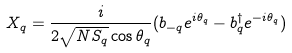Convert formula to latex. <formula><loc_0><loc_0><loc_500><loc_500>X _ { q } = \frac { i } { 2 \sqrt { N S _ { q } } \cos \theta _ { q } } ( b _ { - { q } } e ^ { i \theta _ { q } } - b ^ { \dagger } _ { q } e ^ { - i \theta _ { q } } )</formula> 